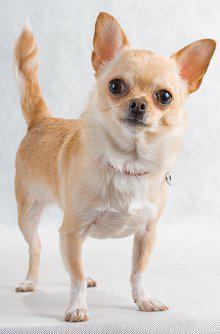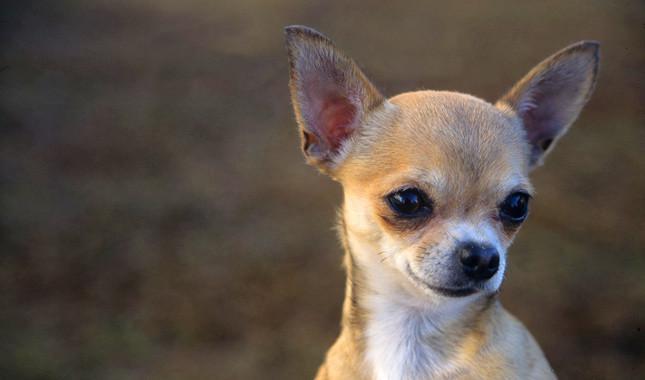The first image is the image on the left, the second image is the image on the right. For the images displayed, is the sentence "At least one dog is wearing a collar." factually correct? Answer yes or no. Yes. 